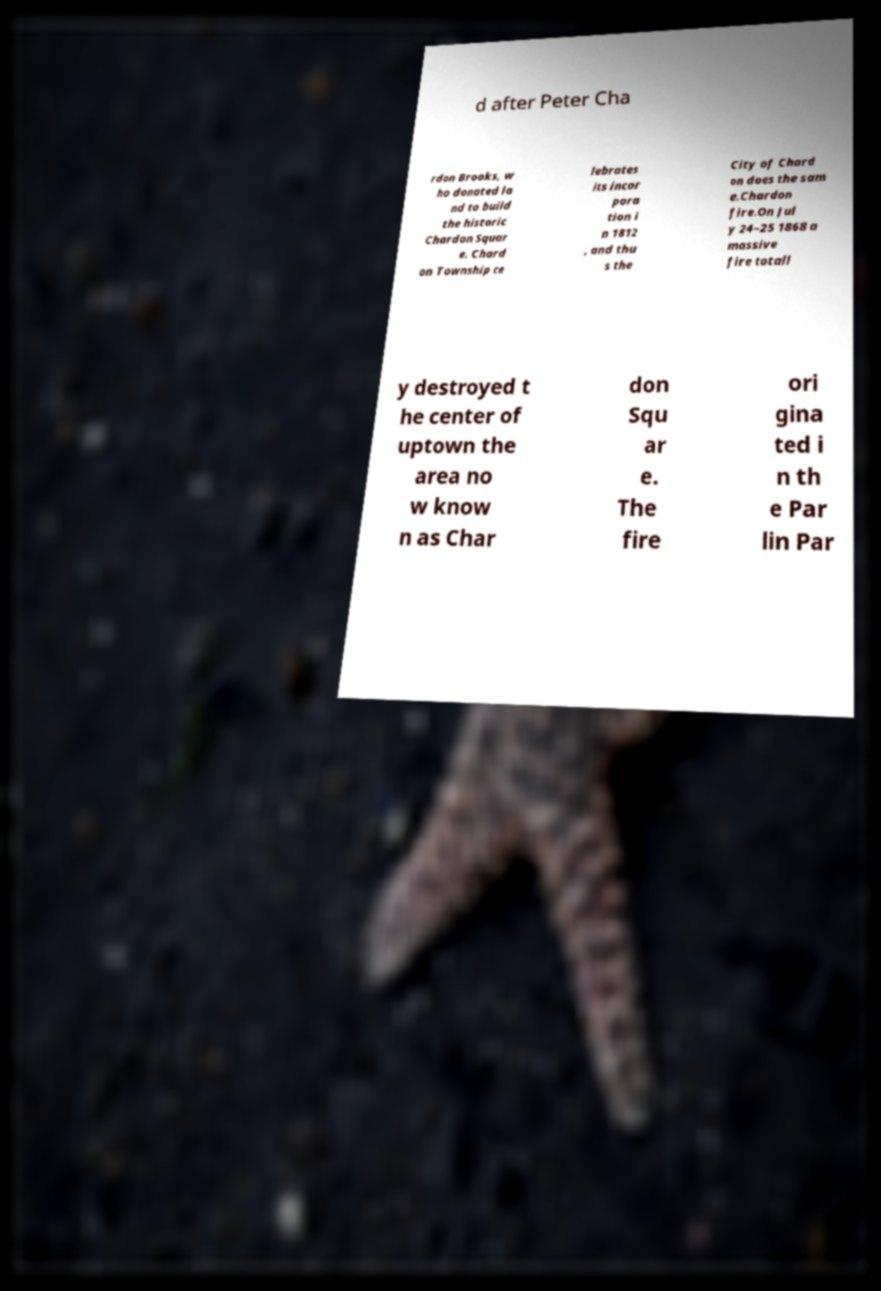Could you assist in decoding the text presented in this image and type it out clearly? d after Peter Cha rdon Brooks, w ho donated la nd to build the historic Chardon Squar e. Chard on Township ce lebrates its incor pora tion i n 1812 , and thu s the City of Chard on does the sam e.Chardon fire.On Jul y 24–25 1868 a massive fire totall y destroyed t he center of uptown the area no w know n as Char don Squ ar e. The fire ori gina ted i n th e Par lin Par 